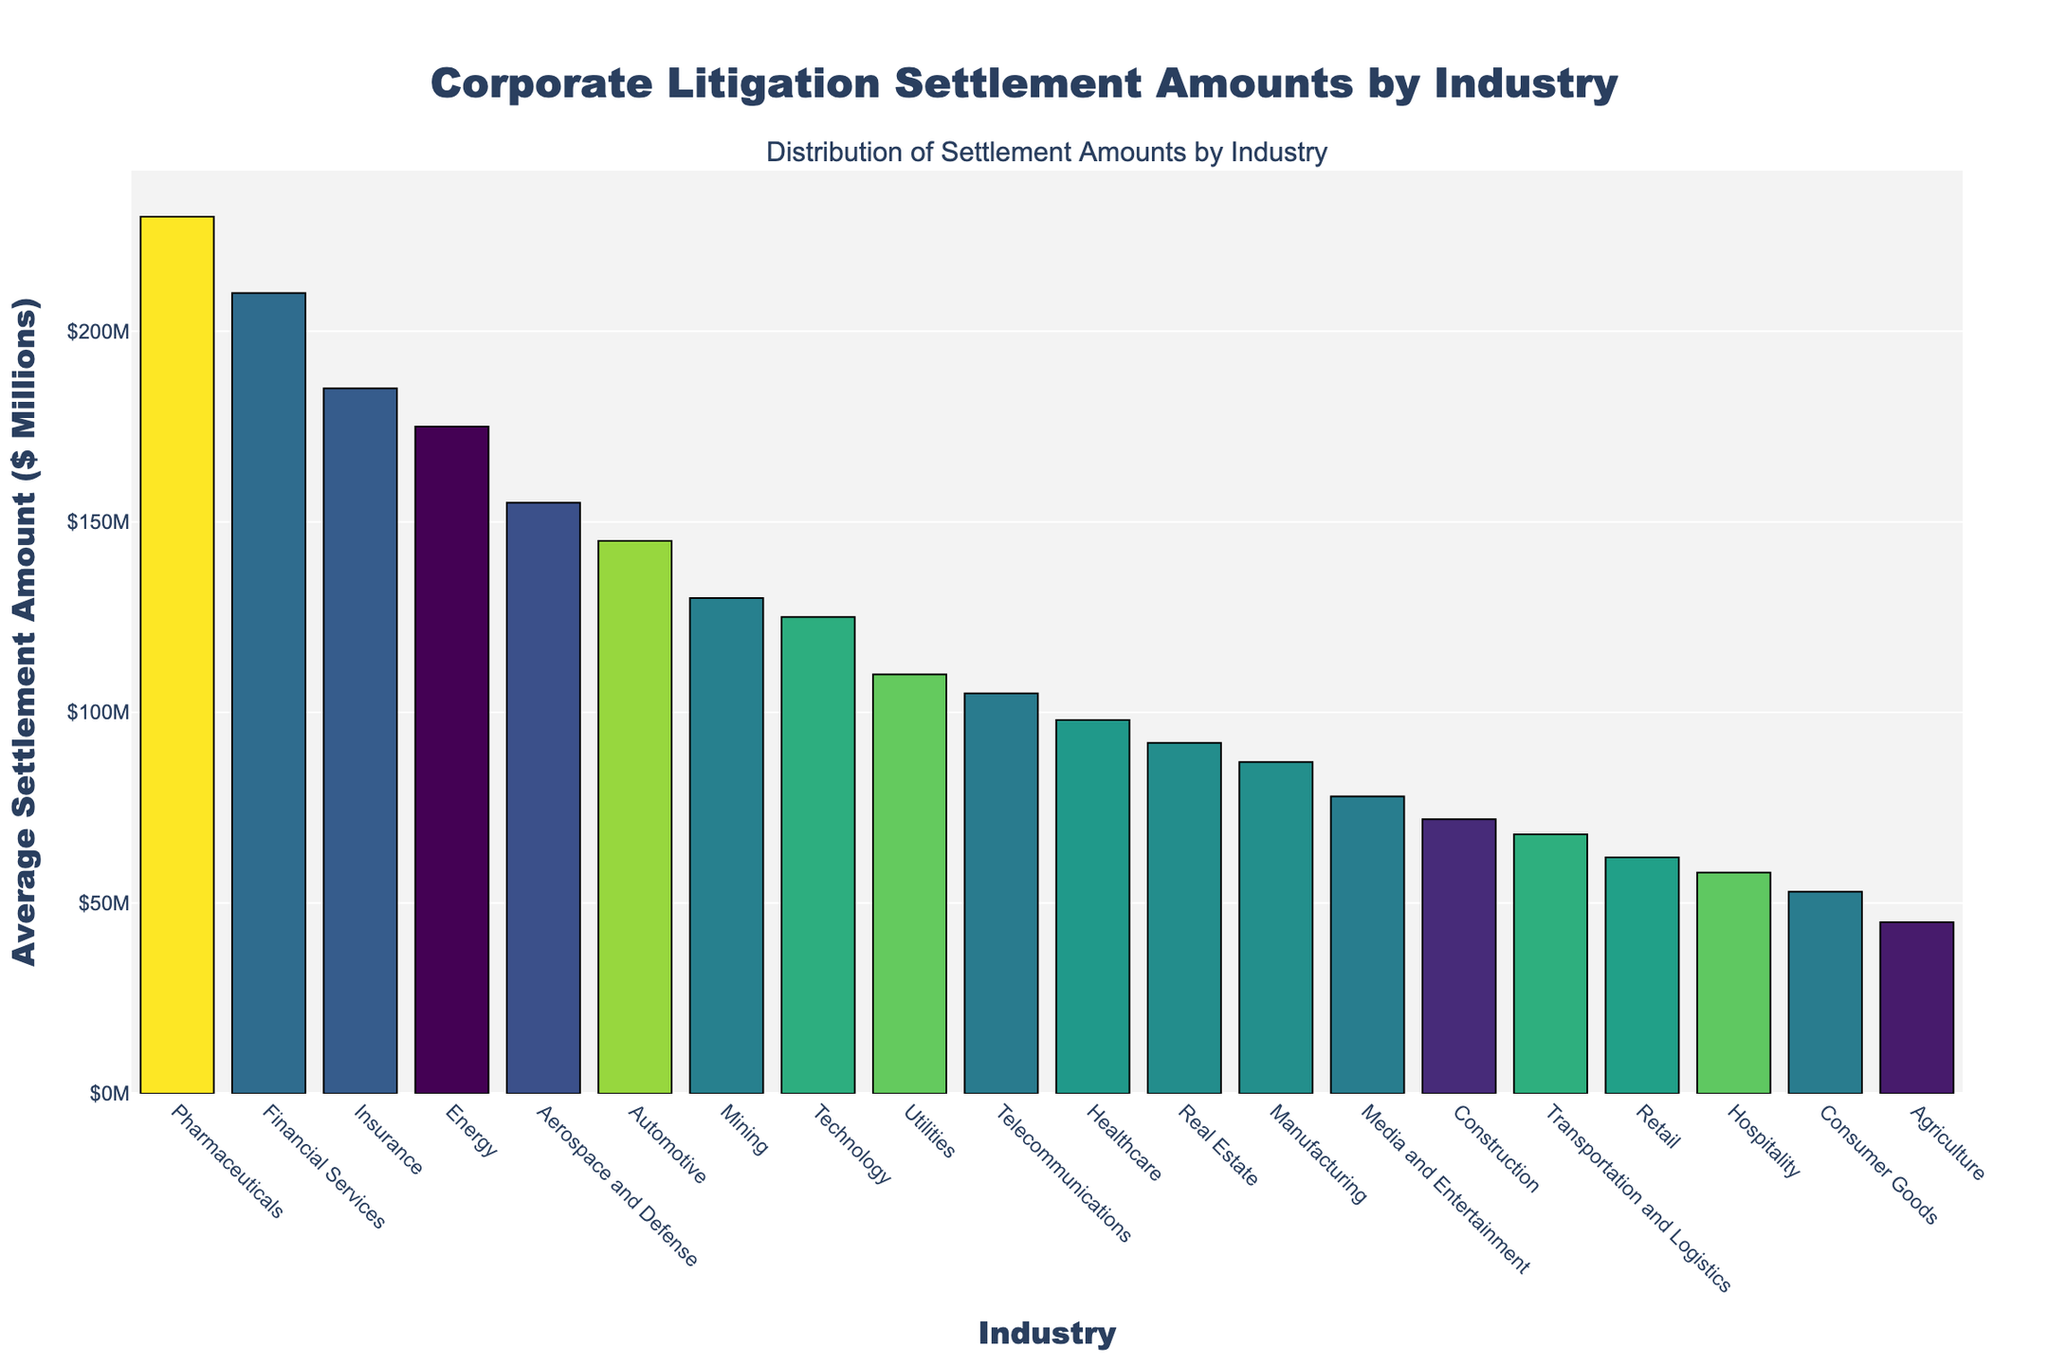Who has the highest average settlement amount? Look for the bar with the greatest height. The "Pharmaceuticals" industry has the tallest bar corresponding to $230 million.
Answer: Pharmaceuticals Which two industries have the lowest average settlement amounts, and what are they? Identify the two shortest bars. The "Agriculture" and "Consumer Goods" industries have the lowest amounts, indicated by $45 million and $53 million, respectively.
Answer: Agriculture and Consumer Goods How does the average settlement amount in the Financial Services industry compare to the Energy industry? Compare the heights of the bars for Financial Services and Energy. Financial Services has a settlement amount of $210 million, while Energy has $175 million.
Answer: Financial Services has a higher amount Which industries have an average settlement amount above $150 million? Identify the bars exceeding the $150 million mark on the y-axis. The industries are Financial Services, Energy, Automotive, Pharmaceuticals, Aerospace and Defense, and Insurance.
Answer: Financial Services, Energy, Automotive, Pharmaceuticals, Aerospace and Defense, Insurance What is the difference in average settlement amounts between Technology and Healthcare? Subtract Healthcare's settlement amount from Technology's amount. Technology is $125 million, and Healthcare is $98 million. $125 million - $98 million = $27 million.
Answer: $27 million What is the combined average settlement amount of Utilities and Telecommunications industries? Add the average settlement amounts of both industries. Utilities is $110 million, and Telecommunications is $105 million. $110 million + $105 million = $215 million.
Answer: $215 million Which industry falls in the middle if you rank them by settlement amounts? Sort industries by height and find the median. With 20 industries, the 10th and 11th values are aggregated and averaged. "Media and Entertainment" and "Construction" represent the median.
Answer: Media and Entertainment, Construction Is the average settlement amount for the Insurance industry greater than that for the Automotive industry? Compare the heights of the bars. Insurance is $185 million, and Automotive is $145 million.
Answer: Yes What is the total average settlement amount for Retail, Manufacturing, and Real Estate industries? Sum their settlement amounts: Retail is $62 million, Manufacturing is $87 million, and Real Estate is $92 million. $62 million + $87 million + $92 million = $241 million.
Answer: $241 million 